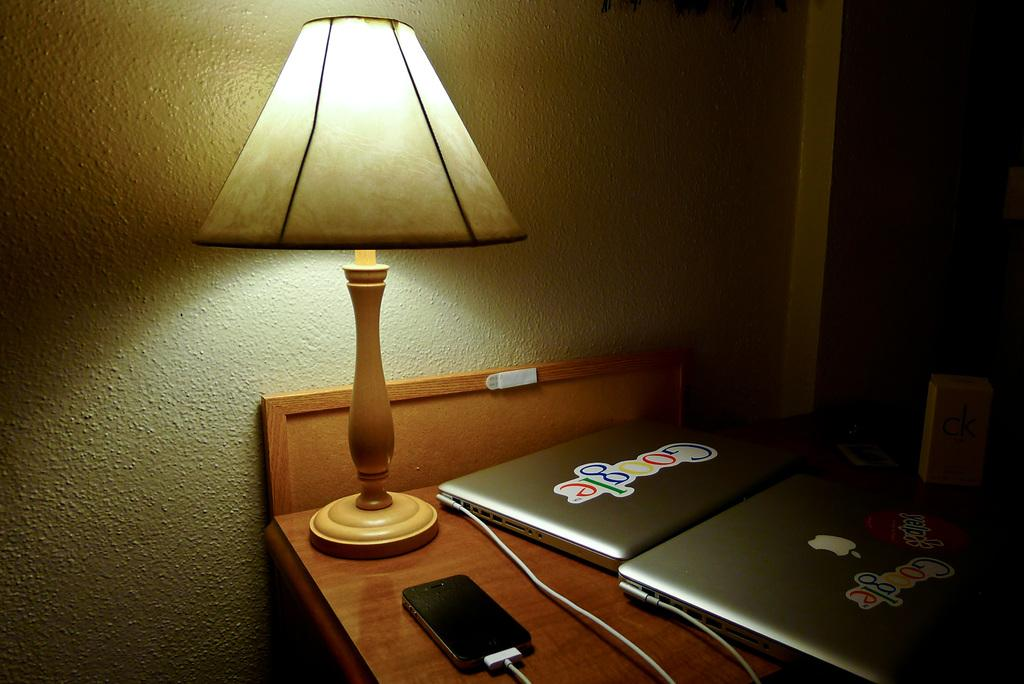What type of lighting is present in the image? There is a table lamp in the image. What else can be seen on the table besides the lamp? There are electronic devices on the table. What is visible in the background of the image? There is a wall in the background of the image. Can you see your uncle looking at his wrist in the image? There is no uncle or wrist visible in the image. 